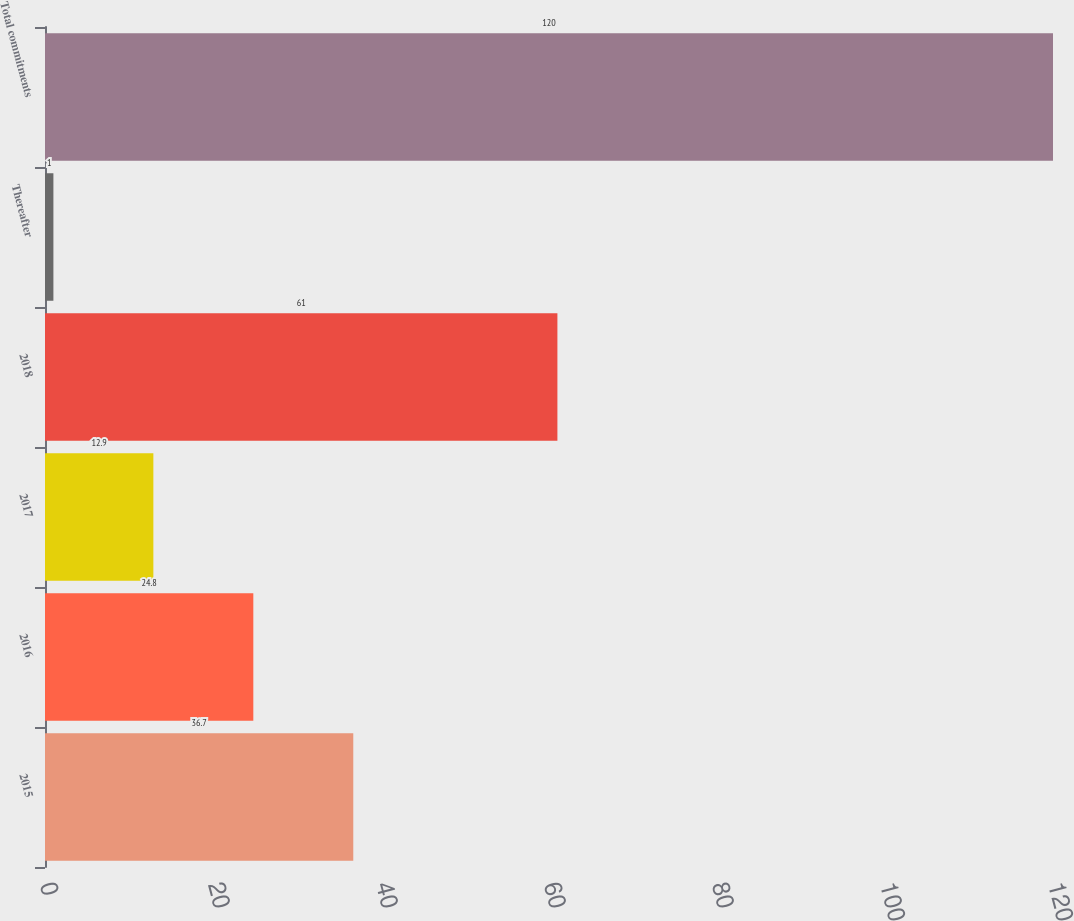Convert chart to OTSL. <chart><loc_0><loc_0><loc_500><loc_500><bar_chart><fcel>2015<fcel>2016<fcel>2017<fcel>2018<fcel>Thereafter<fcel>Total commitments<nl><fcel>36.7<fcel>24.8<fcel>12.9<fcel>61<fcel>1<fcel>120<nl></chart> 